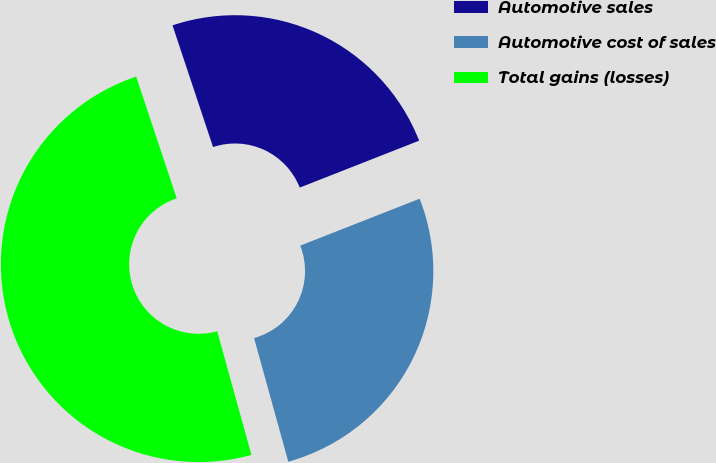Convert chart. <chart><loc_0><loc_0><loc_500><loc_500><pie_chart><fcel>Automotive sales<fcel>Automotive cost of sales<fcel>Total gains (losses)<nl><fcel>24.16%<fcel>26.66%<fcel>49.18%<nl></chart> 